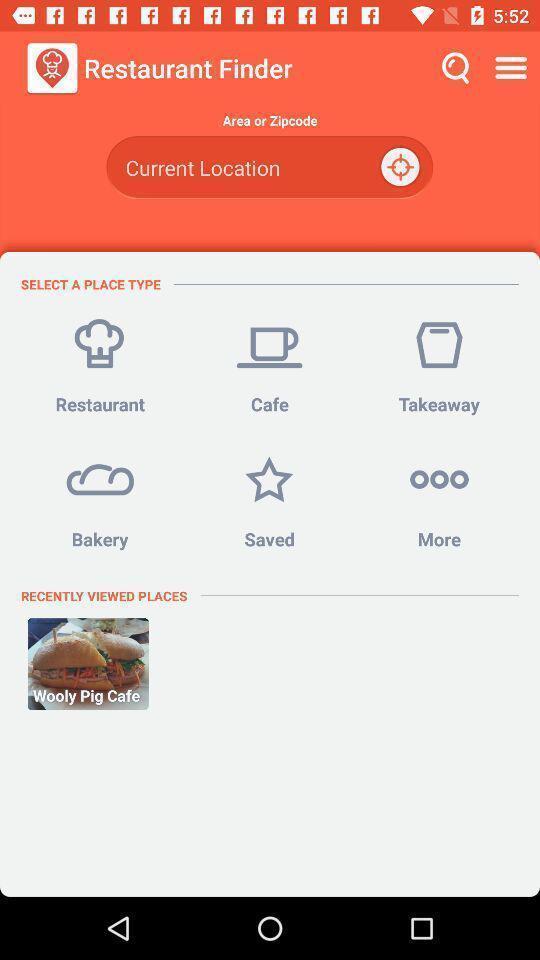What can you discern from this picture? Screen shows to find a restaurant. 